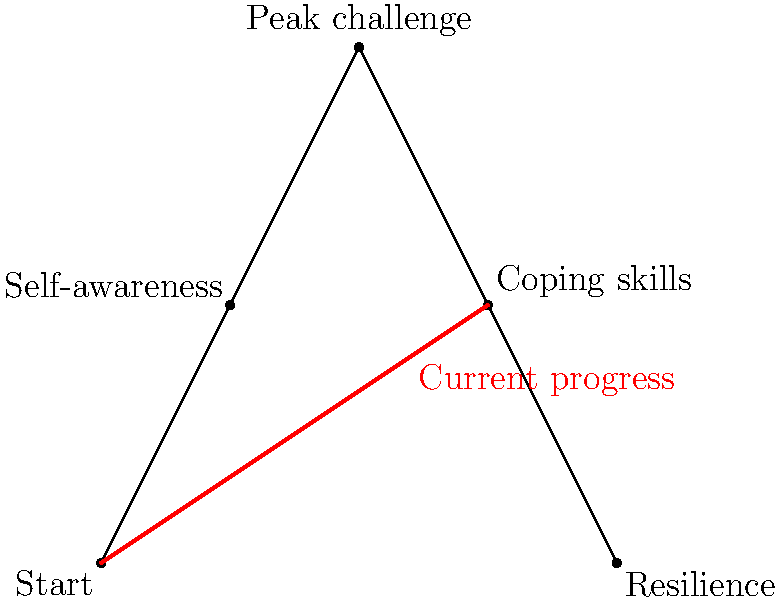In the mountain climbing illustration representing progress in therapy, at which milestone is the current progress indicated? To determine the current progress in therapy as represented by the mountain climbing illustration, we need to follow these steps:

1. Identify the milestones on the mountain:
   - Start (bottom left)
   - Self-awareness (first quarter up)
   - Peak challenge (top of the mountain)
   - Coping skills (third quarter, descending)
   - Resilience (bottom right)

2. Locate the red line indicating current progress:
   - The red line starts at the "Start" point
   - It extends past "Self-awareness"
   - It reaches the "Coping skills" milestone

3. Analyze the progress:
   - The progress line has moved beyond "Self-awareness"
   - It has not yet reached the "Peak challenge"
   - It ends exactly at the "Coping skills" milestone

4. Interpret the meaning:
   - In therapy terms, this suggests the individual has developed self-awareness
   - They are currently working on or have just reached the stage of developing coping skills
   - They have not yet faced their peak challenge or fully developed resilience

Therefore, the current progress in therapy is indicated at the "Coping skills" milestone.
Answer: Coping skills 